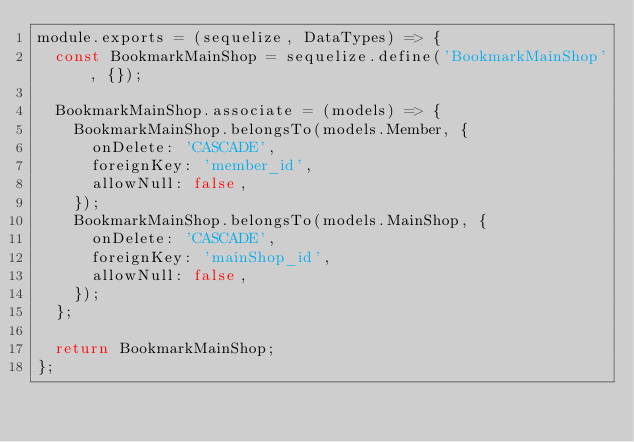Convert code to text. <code><loc_0><loc_0><loc_500><loc_500><_JavaScript_>module.exports = (sequelize, DataTypes) => {
  const BookmarkMainShop = sequelize.define('BookmarkMainShop', {});

  BookmarkMainShop.associate = (models) => {
    BookmarkMainShop.belongsTo(models.Member, {
      onDelete: 'CASCADE',
      foreignKey: 'member_id',
      allowNull: false,
    });
    BookmarkMainShop.belongsTo(models.MainShop, {
      onDelete: 'CASCADE',
      foreignKey: 'mainShop_id',
      allowNull: false,
    });
  };

  return BookmarkMainShop;
};
</code> 